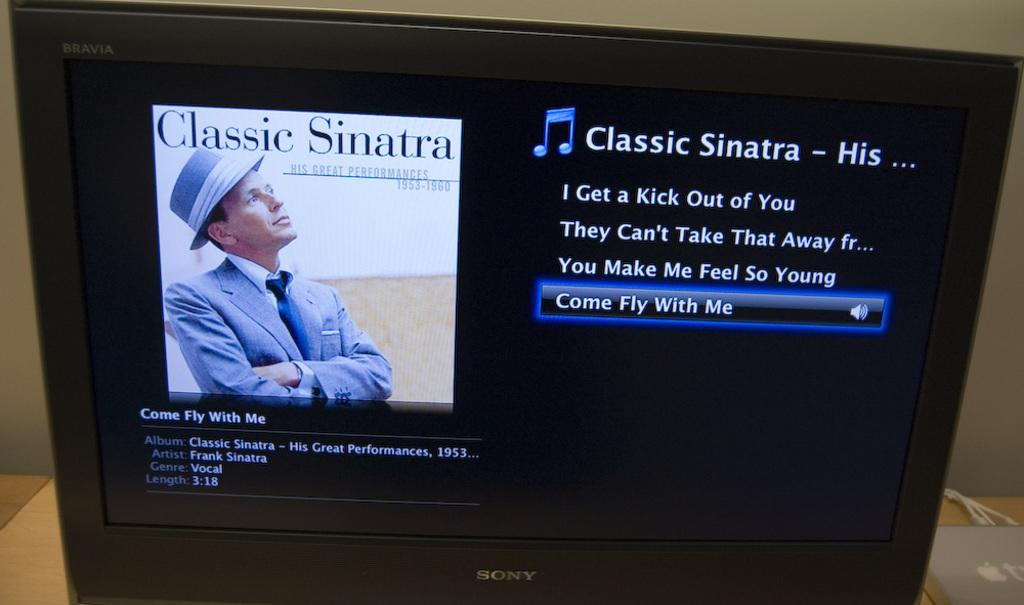<image>
Relay a brief, clear account of the picture shown. A screen shows that classic Sinatra tunes can be selected for play. 